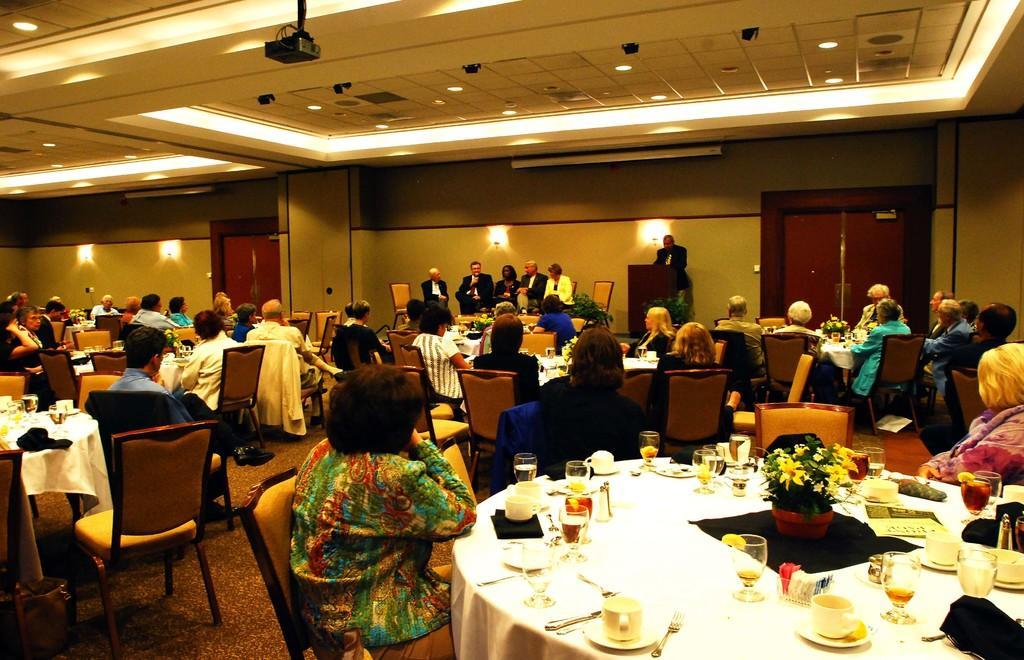In one or two sentences, can you explain what this image depicts? In the image we can see group of persons were sitting on the chair around the table. On the table we can see cup,saucer,fork,glass,cloth,napkin,flower pot,paper etc. In the background there is a wall,door,light,wood stand and few other objects. 